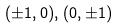<formula> <loc_0><loc_0><loc_500><loc_500>( \pm 1 , 0 ) , ( 0 , \pm 1 )</formula> 